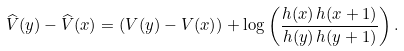<formula> <loc_0><loc_0><loc_500><loc_500>\widehat { V } ( y ) - \widehat { V } ( x ) = \left ( V ( y ) - V ( x ) \right ) + \log \left ( \frac { h ( x ) \, h ( x + 1 ) } { h ( y ) \, h ( y + 1 ) } \right ) .</formula> 